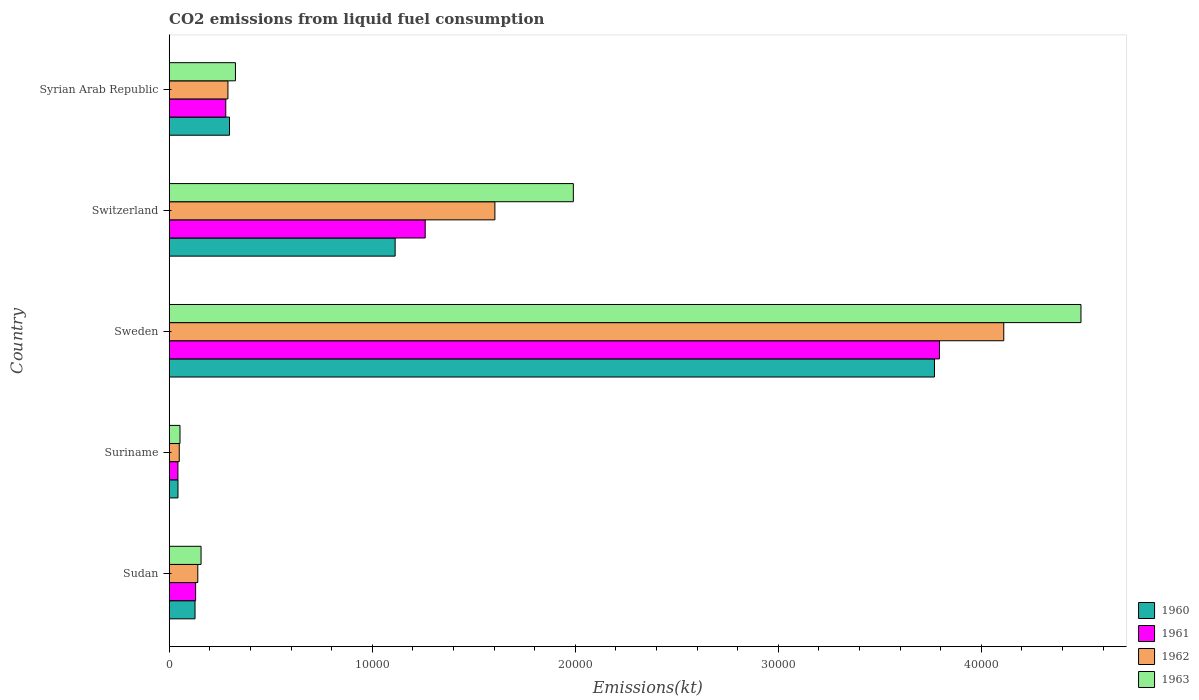How many different coloured bars are there?
Offer a very short reply. 4. Are the number of bars on each tick of the Y-axis equal?
Keep it short and to the point. Yes. How many bars are there on the 5th tick from the top?
Your answer should be very brief. 4. How many bars are there on the 2nd tick from the bottom?
Offer a very short reply. 4. What is the label of the 3rd group of bars from the top?
Your answer should be very brief. Sweden. What is the amount of CO2 emitted in 1960 in Syrian Arab Republic?
Provide a short and direct response. 2970.27. Across all countries, what is the maximum amount of CO2 emitted in 1961?
Provide a short and direct response. 3.79e+04. Across all countries, what is the minimum amount of CO2 emitted in 1962?
Your response must be concise. 495.05. In which country was the amount of CO2 emitted in 1960 minimum?
Make the answer very short. Suriname. What is the total amount of CO2 emitted in 1961 in the graph?
Provide a succinct answer. 5.51e+04. What is the difference between the amount of CO2 emitted in 1961 in Sweden and that in Switzerland?
Give a very brief answer. 2.53e+04. What is the difference between the amount of CO2 emitted in 1960 in Syrian Arab Republic and the amount of CO2 emitted in 1963 in Sweden?
Ensure brevity in your answer.  -4.19e+04. What is the average amount of CO2 emitted in 1963 per country?
Your answer should be compact. 1.40e+04. What is the difference between the amount of CO2 emitted in 1961 and amount of CO2 emitted in 1963 in Suriname?
Your answer should be compact. -102.68. In how many countries, is the amount of CO2 emitted in 1960 greater than 22000 kt?
Give a very brief answer. 1. What is the ratio of the amount of CO2 emitted in 1961 in Suriname to that in Syrian Arab Republic?
Give a very brief answer. 0.15. Is the amount of CO2 emitted in 1961 in Suriname less than that in Sweden?
Your answer should be compact. Yes. What is the difference between the highest and the second highest amount of CO2 emitted in 1961?
Offer a very short reply. 2.53e+04. What is the difference between the highest and the lowest amount of CO2 emitted in 1961?
Provide a short and direct response. 3.75e+04. In how many countries, is the amount of CO2 emitted in 1963 greater than the average amount of CO2 emitted in 1963 taken over all countries?
Provide a succinct answer. 2. Is it the case that in every country, the sum of the amount of CO2 emitted in 1963 and amount of CO2 emitted in 1961 is greater than the sum of amount of CO2 emitted in 1962 and amount of CO2 emitted in 1960?
Your answer should be compact. No. What does the 2nd bar from the top in Switzerland represents?
Offer a very short reply. 1962. How many bars are there?
Ensure brevity in your answer.  20. Does the graph contain any zero values?
Ensure brevity in your answer.  No. How many legend labels are there?
Make the answer very short. 4. How are the legend labels stacked?
Your response must be concise. Vertical. What is the title of the graph?
Provide a succinct answer. CO2 emissions from liquid fuel consumption. Does "1992" appear as one of the legend labels in the graph?
Provide a succinct answer. No. What is the label or title of the X-axis?
Your answer should be compact. Emissions(kt). What is the Emissions(kt) in 1960 in Sudan?
Offer a terse response. 1272.45. What is the Emissions(kt) in 1961 in Sudan?
Provide a short and direct response. 1301.79. What is the Emissions(kt) of 1962 in Sudan?
Make the answer very short. 1408.13. What is the Emissions(kt) of 1963 in Sudan?
Provide a succinct answer. 1569.48. What is the Emissions(kt) in 1960 in Suriname?
Keep it short and to the point. 432.71. What is the Emissions(kt) in 1961 in Suriname?
Your answer should be compact. 429.04. What is the Emissions(kt) in 1962 in Suriname?
Keep it short and to the point. 495.05. What is the Emissions(kt) of 1963 in Suriname?
Your answer should be very brief. 531.72. What is the Emissions(kt) in 1960 in Sweden?
Your answer should be very brief. 3.77e+04. What is the Emissions(kt) in 1961 in Sweden?
Make the answer very short. 3.79e+04. What is the Emissions(kt) of 1962 in Sweden?
Your response must be concise. 4.11e+04. What is the Emissions(kt) of 1963 in Sweden?
Keep it short and to the point. 4.49e+04. What is the Emissions(kt) in 1960 in Switzerland?
Make the answer very short. 1.11e+04. What is the Emissions(kt) of 1961 in Switzerland?
Offer a terse response. 1.26e+04. What is the Emissions(kt) of 1962 in Switzerland?
Keep it short and to the point. 1.60e+04. What is the Emissions(kt) in 1963 in Switzerland?
Offer a very short reply. 1.99e+04. What is the Emissions(kt) in 1960 in Syrian Arab Republic?
Offer a very short reply. 2970.27. What is the Emissions(kt) of 1961 in Syrian Arab Republic?
Provide a succinct answer. 2786.92. What is the Emissions(kt) of 1962 in Syrian Arab Republic?
Your response must be concise. 2893.26. What is the Emissions(kt) of 1963 in Syrian Arab Republic?
Your answer should be very brief. 3263.63. Across all countries, what is the maximum Emissions(kt) in 1960?
Your answer should be very brief. 3.77e+04. Across all countries, what is the maximum Emissions(kt) in 1961?
Provide a short and direct response. 3.79e+04. Across all countries, what is the maximum Emissions(kt) in 1962?
Your response must be concise. 4.11e+04. Across all countries, what is the maximum Emissions(kt) in 1963?
Provide a succinct answer. 4.49e+04. Across all countries, what is the minimum Emissions(kt) in 1960?
Keep it short and to the point. 432.71. Across all countries, what is the minimum Emissions(kt) of 1961?
Provide a short and direct response. 429.04. Across all countries, what is the minimum Emissions(kt) in 1962?
Ensure brevity in your answer.  495.05. Across all countries, what is the minimum Emissions(kt) of 1963?
Your answer should be very brief. 531.72. What is the total Emissions(kt) in 1960 in the graph?
Offer a terse response. 5.35e+04. What is the total Emissions(kt) in 1961 in the graph?
Your answer should be compact. 5.51e+04. What is the total Emissions(kt) of 1962 in the graph?
Provide a succinct answer. 6.20e+04. What is the total Emissions(kt) of 1963 in the graph?
Your answer should be very brief. 7.02e+04. What is the difference between the Emissions(kt) in 1960 in Sudan and that in Suriname?
Provide a short and direct response. 839.74. What is the difference between the Emissions(kt) of 1961 in Sudan and that in Suriname?
Offer a very short reply. 872.75. What is the difference between the Emissions(kt) of 1962 in Sudan and that in Suriname?
Provide a succinct answer. 913.08. What is the difference between the Emissions(kt) in 1963 in Sudan and that in Suriname?
Provide a succinct answer. 1037.76. What is the difference between the Emissions(kt) in 1960 in Sudan and that in Sweden?
Offer a terse response. -3.64e+04. What is the difference between the Emissions(kt) of 1961 in Sudan and that in Sweden?
Make the answer very short. -3.66e+04. What is the difference between the Emissions(kt) of 1962 in Sudan and that in Sweden?
Ensure brevity in your answer.  -3.97e+04. What is the difference between the Emissions(kt) of 1963 in Sudan and that in Sweden?
Provide a short and direct response. -4.33e+04. What is the difference between the Emissions(kt) of 1960 in Sudan and that in Switzerland?
Provide a succinct answer. -9856.9. What is the difference between the Emissions(kt) in 1961 in Sudan and that in Switzerland?
Ensure brevity in your answer.  -1.13e+04. What is the difference between the Emissions(kt) of 1962 in Sudan and that in Switzerland?
Your response must be concise. -1.46e+04. What is the difference between the Emissions(kt) in 1963 in Sudan and that in Switzerland?
Your response must be concise. -1.83e+04. What is the difference between the Emissions(kt) in 1960 in Sudan and that in Syrian Arab Republic?
Offer a terse response. -1697.82. What is the difference between the Emissions(kt) of 1961 in Sudan and that in Syrian Arab Republic?
Provide a short and direct response. -1485.13. What is the difference between the Emissions(kt) in 1962 in Sudan and that in Syrian Arab Republic?
Offer a terse response. -1485.13. What is the difference between the Emissions(kt) in 1963 in Sudan and that in Syrian Arab Republic?
Offer a very short reply. -1694.15. What is the difference between the Emissions(kt) in 1960 in Suriname and that in Sweden?
Ensure brevity in your answer.  -3.73e+04. What is the difference between the Emissions(kt) in 1961 in Suriname and that in Sweden?
Make the answer very short. -3.75e+04. What is the difference between the Emissions(kt) of 1962 in Suriname and that in Sweden?
Make the answer very short. -4.06e+04. What is the difference between the Emissions(kt) of 1963 in Suriname and that in Sweden?
Your response must be concise. -4.44e+04. What is the difference between the Emissions(kt) in 1960 in Suriname and that in Switzerland?
Offer a very short reply. -1.07e+04. What is the difference between the Emissions(kt) in 1961 in Suriname and that in Switzerland?
Offer a terse response. -1.22e+04. What is the difference between the Emissions(kt) in 1962 in Suriname and that in Switzerland?
Provide a short and direct response. -1.55e+04. What is the difference between the Emissions(kt) of 1963 in Suriname and that in Switzerland?
Provide a short and direct response. -1.94e+04. What is the difference between the Emissions(kt) in 1960 in Suriname and that in Syrian Arab Republic?
Keep it short and to the point. -2537.56. What is the difference between the Emissions(kt) of 1961 in Suriname and that in Syrian Arab Republic?
Keep it short and to the point. -2357.88. What is the difference between the Emissions(kt) in 1962 in Suriname and that in Syrian Arab Republic?
Keep it short and to the point. -2398.22. What is the difference between the Emissions(kt) of 1963 in Suriname and that in Syrian Arab Republic?
Ensure brevity in your answer.  -2731.91. What is the difference between the Emissions(kt) in 1960 in Sweden and that in Switzerland?
Keep it short and to the point. 2.66e+04. What is the difference between the Emissions(kt) of 1961 in Sweden and that in Switzerland?
Provide a short and direct response. 2.53e+04. What is the difference between the Emissions(kt) of 1962 in Sweden and that in Switzerland?
Keep it short and to the point. 2.51e+04. What is the difference between the Emissions(kt) in 1963 in Sweden and that in Switzerland?
Give a very brief answer. 2.50e+04. What is the difference between the Emissions(kt) of 1960 in Sweden and that in Syrian Arab Republic?
Offer a very short reply. 3.47e+04. What is the difference between the Emissions(kt) in 1961 in Sweden and that in Syrian Arab Republic?
Your response must be concise. 3.52e+04. What is the difference between the Emissions(kt) of 1962 in Sweden and that in Syrian Arab Republic?
Offer a terse response. 3.82e+04. What is the difference between the Emissions(kt) of 1963 in Sweden and that in Syrian Arab Republic?
Your response must be concise. 4.16e+04. What is the difference between the Emissions(kt) in 1960 in Switzerland and that in Syrian Arab Republic?
Keep it short and to the point. 8159.07. What is the difference between the Emissions(kt) in 1961 in Switzerland and that in Syrian Arab Republic?
Your answer should be very brief. 9823.89. What is the difference between the Emissions(kt) of 1962 in Switzerland and that in Syrian Arab Republic?
Your answer should be very brief. 1.31e+04. What is the difference between the Emissions(kt) of 1963 in Switzerland and that in Syrian Arab Republic?
Make the answer very short. 1.66e+04. What is the difference between the Emissions(kt) of 1960 in Sudan and the Emissions(kt) of 1961 in Suriname?
Provide a succinct answer. 843.41. What is the difference between the Emissions(kt) in 1960 in Sudan and the Emissions(kt) in 1962 in Suriname?
Give a very brief answer. 777.4. What is the difference between the Emissions(kt) of 1960 in Sudan and the Emissions(kt) of 1963 in Suriname?
Offer a terse response. 740.73. What is the difference between the Emissions(kt) of 1961 in Sudan and the Emissions(kt) of 1962 in Suriname?
Make the answer very short. 806.74. What is the difference between the Emissions(kt) in 1961 in Sudan and the Emissions(kt) in 1963 in Suriname?
Your response must be concise. 770.07. What is the difference between the Emissions(kt) in 1962 in Sudan and the Emissions(kt) in 1963 in Suriname?
Your response must be concise. 876.41. What is the difference between the Emissions(kt) in 1960 in Sudan and the Emissions(kt) in 1961 in Sweden?
Offer a terse response. -3.67e+04. What is the difference between the Emissions(kt) of 1960 in Sudan and the Emissions(kt) of 1962 in Sweden?
Make the answer very short. -3.98e+04. What is the difference between the Emissions(kt) of 1960 in Sudan and the Emissions(kt) of 1963 in Sweden?
Your response must be concise. -4.36e+04. What is the difference between the Emissions(kt) in 1961 in Sudan and the Emissions(kt) in 1962 in Sweden?
Your response must be concise. -3.98e+04. What is the difference between the Emissions(kt) in 1961 in Sudan and the Emissions(kt) in 1963 in Sweden?
Keep it short and to the point. -4.36e+04. What is the difference between the Emissions(kt) in 1962 in Sudan and the Emissions(kt) in 1963 in Sweden?
Offer a terse response. -4.35e+04. What is the difference between the Emissions(kt) in 1960 in Sudan and the Emissions(kt) in 1961 in Switzerland?
Provide a short and direct response. -1.13e+04. What is the difference between the Emissions(kt) in 1960 in Sudan and the Emissions(kt) in 1962 in Switzerland?
Give a very brief answer. -1.48e+04. What is the difference between the Emissions(kt) in 1960 in Sudan and the Emissions(kt) in 1963 in Switzerland?
Make the answer very short. -1.86e+04. What is the difference between the Emissions(kt) of 1961 in Sudan and the Emissions(kt) of 1962 in Switzerland?
Make the answer very short. -1.47e+04. What is the difference between the Emissions(kt) in 1961 in Sudan and the Emissions(kt) in 1963 in Switzerland?
Ensure brevity in your answer.  -1.86e+04. What is the difference between the Emissions(kt) in 1962 in Sudan and the Emissions(kt) in 1963 in Switzerland?
Your answer should be compact. -1.85e+04. What is the difference between the Emissions(kt) of 1960 in Sudan and the Emissions(kt) of 1961 in Syrian Arab Republic?
Your answer should be very brief. -1514.47. What is the difference between the Emissions(kt) of 1960 in Sudan and the Emissions(kt) of 1962 in Syrian Arab Republic?
Your answer should be compact. -1620.81. What is the difference between the Emissions(kt) in 1960 in Sudan and the Emissions(kt) in 1963 in Syrian Arab Republic?
Give a very brief answer. -1991.18. What is the difference between the Emissions(kt) of 1961 in Sudan and the Emissions(kt) of 1962 in Syrian Arab Republic?
Your answer should be compact. -1591.48. What is the difference between the Emissions(kt) in 1961 in Sudan and the Emissions(kt) in 1963 in Syrian Arab Republic?
Make the answer very short. -1961.85. What is the difference between the Emissions(kt) of 1962 in Sudan and the Emissions(kt) of 1963 in Syrian Arab Republic?
Offer a very short reply. -1855.5. What is the difference between the Emissions(kt) in 1960 in Suriname and the Emissions(kt) in 1961 in Sweden?
Keep it short and to the point. -3.75e+04. What is the difference between the Emissions(kt) of 1960 in Suriname and the Emissions(kt) of 1962 in Sweden?
Provide a short and direct response. -4.07e+04. What is the difference between the Emissions(kt) in 1960 in Suriname and the Emissions(kt) in 1963 in Sweden?
Your answer should be very brief. -4.45e+04. What is the difference between the Emissions(kt) of 1961 in Suriname and the Emissions(kt) of 1962 in Sweden?
Your answer should be very brief. -4.07e+04. What is the difference between the Emissions(kt) in 1961 in Suriname and the Emissions(kt) in 1963 in Sweden?
Offer a very short reply. -4.45e+04. What is the difference between the Emissions(kt) of 1962 in Suriname and the Emissions(kt) of 1963 in Sweden?
Make the answer very short. -4.44e+04. What is the difference between the Emissions(kt) in 1960 in Suriname and the Emissions(kt) in 1961 in Switzerland?
Offer a terse response. -1.22e+04. What is the difference between the Emissions(kt) in 1960 in Suriname and the Emissions(kt) in 1962 in Switzerland?
Provide a succinct answer. -1.56e+04. What is the difference between the Emissions(kt) in 1960 in Suriname and the Emissions(kt) in 1963 in Switzerland?
Provide a succinct answer. -1.95e+04. What is the difference between the Emissions(kt) of 1961 in Suriname and the Emissions(kt) of 1962 in Switzerland?
Your response must be concise. -1.56e+04. What is the difference between the Emissions(kt) of 1961 in Suriname and the Emissions(kt) of 1963 in Switzerland?
Give a very brief answer. -1.95e+04. What is the difference between the Emissions(kt) in 1962 in Suriname and the Emissions(kt) in 1963 in Switzerland?
Offer a very short reply. -1.94e+04. What is the difference between the Emissions(kt) in 1960 in Suriname and the Emissions(kt) in 1961 in Syrian Arab Republic?
Provide a succinct answer. -2354.21. What is the difference between the Emissions(kt) in 1960 in Suriname and the Emissions(kt) in 1962 in Syrian Arab Republic?
Keep it short and to the point. -2460.56. What is the difference between the Emissions(kt) of 1960 in Suriname and the Emissions(kt) of 1963 in Syrian Arab Republic?
Offer a terse response. -2830.92. What is the difference between the Emissions(kt) of 1961 in Suriname and the Emissions(kt) of 1962 in Syrian Arab Republic?
Ensure brevity in your answer.  -2464.22. What is the difference between the Emissions(kt) of 1961 in Suriname and the Emissions(kt) of 1963 in Syrian Arab Republic?
Give a very brief answer. -2834.59. What is the difference between the Emissions(kt) in 1962 in Suriname and the Emissions(kt) in 1963 in Syrian Arab Republic?
Give a very brief answer. -2768.59. What is the difference between the Emissions(kt) of 1960 in Sweden and the Emissions(kt) of 1961 in Switzerland?
Make the answer very short. 2.51e+04. What is the difference between the Emissions(kt) in 1960 in Sweden and the Emissions(kt) in 1962 in Switzerland?
Offer a very short reply. 2.17e+04. What is the difference between the Emissions(kt) in 1960 in Sweden and the Emissions(kt) in 1963 in Switzerland?
Keep it short and to the point. 1.78e+04. What is the difference between the Emissions(kt) of 1961 in Sweden and the Emissions(kt) of 1962 in Switzerland?
Provide a succinct answer. 2.19e+04. What is the difference between the Emissions(kt) of 1961 in Sweden and the Emissions(kt) of 1963 in Switzerland?
Offer a very short reply. 1.80e+04. What is the difference between the Emissions(kt) in 1962 in Sweden and the Emissions(kt) in 1963 in Switzerland?
Offer a terse response. 2.12e+04. What is the difference between the Emissions(kt) in 1960 in Sweden and the Emissions(kt) in 1961 in Syrian Arab Republic?
Offer a very short reply. 3.49e+04. What is the difference between the Emissions(kt) in 1960 in Sweden and the Emissions(kt) in 1962 in Syrian Arab Republic?
Provide a succinct answer. 3.48e+04. What is the difference between the Emissions(kt) of 1960 in Sweden and the Emissions(kt) of 1963 in Syrian Arab Republic?
Make the answer very short. 3.44e+04. What is the difference between the Emissions(kt) in 1961 in Sweden and the Emissions(kt) in 1962 in Syrian Arab Republic?
Provide a succinct answer. 3.50e+04. What is the difference between the Emissions(kt) of 1961 in Sweden and the Emissions(kt) of 1963 in Syrian Arab Republic?
Keep it short and to the point. 3.47e+04. What is the difference between the Emissions(kt) of 1962 in Sweden and the Emissions(kt) of 1963 in Syrian Arab Republic?
Give a very brief answer. 3.78e+04. What is the difference between the Emissions(kt) of 1960 in Switzerland and the Emissions(kt) of 1961 in Syrian Arab Republic?
Keep it short and to the point. 8342.42. What is the difference between the Emissions(kt) of 1960 in Switzerland and the Emissions(kt) of 1962 in Syrian Arab Republic?
Give a very brief answer. 8236.08. What is the difference between the Emissions(kt) in 1960 in Switzerland and the Emissions(kt) in 1963 in Syrian Arab Republic?
Your answer should be very brief. 7865.72. What is the difference between the Emissions(kt) of 1961 in Switzerland and the Emissions(kt) of 1962 in Syrian Arab Republic?
Give a very brief answer. 9717.55. What is the difference between the Emissions(kt) of 1961 in Switzerland and the Emissions(kt) of 1963 in Syrian Arab Republic?
Your response must be concise. 9347.18. What is the difference between the Emissions(kt) of 1962 in Switzerland and the Emissions(kt) of 1963 in Syrian Arab Republic?
Keep it short and to the point. 1.28e+04. What is the average Emissions(kt) of 1960 per country?
Keep it short and to the point. 1.07e+04. What is the average Emissions(kt) of 1961 per country?
Your answer should be compact. 1.10e+04. What is the average Emissions(kt) in 1962 per country?
Provide a succinct answer. 1.24e+04. What is the average Emissions(kt) of 1963 per country?
Offer a terse response. 1.40e+04. What is the difference between the Emissions(kt) in 1960 and Emissions(kt) in 1961 in Sudan?
Your answer should be compact. -29.34. What is the difference between the Emissions(kt) of 1960 and Emissions(kt) of 1962 in Sudan?
Your answer should be very brief. -135.68. What is the difference between the Emissions(kt) in 1960 and Emissions(kt) in 1963 in Sudan?
Your answer should be compact. -297.03. What is the difference between the Emissions(kt) in 1961 and Emissions(kt) in 1962 in Sudan?
Make the answer very short. -106.34. What is the difference between the Emissions(kt) of 1961 and Emissions(kt) of 1963 in Sudan?
Offer a terse response. -267.69. What is the difference between the Emissions(kt) of 1962 and Emissions(kt) of 1963 in Sudan?
Ensure brevity in your answer.  -161.35. What is the difference between the Emissions(kt) of 1960 and Emissions(kt) of 1961 in Suriname?
Your answer should be very brief. 3.67. What is the difference between the Emissions(kt) in 1960 and Emissions(kt) in 1962 in Suriname?
Ensure brevity in your answer.  -62.34. What is the difference between the Emissions(kt) of 1960 and Emissions(kt) of 1963 in Suriname?
Your answer should be compact. -99.01. What is the difference between the Emissions(kt) in 1961 and Emissions(kt) in 1962 in Suriname?
Your response must be concise. -66.01. What is the difference between the Emissions(kt) of 1961 and Emissions(kt) of 1963 in Suriname?
Offer a very short reply. -102.68. What is the difference between the Emissions(kt) of 1962 and Emissions(kt) of 1963 in Suriname?
Provide a short and direct response. -36.67. What is the difference between the Emissions(kt) of 1960 and Emissions(kt) of 1961 in Sweden?
Offer a terse response. -245.69. What is the difference between the Emissions(kt) in 1960 and Emissions(kt) in 1962 in Sweden?
Offer a very short reply. -3413.98. What is the difference between the Emissions(kt) of 1960 and Emissions(kt) of 1963 in Sweden?
Offer a terse response. -7216.66. What is the difference between the Emissions(kt) in 1961 and Emissions(kt) in 1962 in Sweden?
Ensure brevity in your answer.  -3168.29. What is the difference between the Emissions(kt) in 1961 and Emissions(kt) in 1963 in Sweden?
Provide a short and direct response. -6970.97. What is the difference between the Emissions(kt) of 1962 and Emissions(kt) of 1963 in Sweden?
Provide a short and direct response. -3802.68. What is the difference between the Emissions(kt) of 1960 and Emissions(kt) of 1961 in Switzerland?
Your answer should be compact. -1481.47. What is the difference between the Emissions(kt) of 1960 and Emissions(kt) of 1962 in Switzerland?
Your response must be concise. -4913.78. What is the difference between the Emissions(kt) in 1960 and Emissions(kt) in 1963 in Switzerland?
Offer a very short reply. -8778.8. What is the difference between the Emissions(kt) in 1961 and Emissions(kt) in 1962 in Switzerland?
Keep it short and to the point. -3432.31. What is the difference between the Emissions(kt) of 1961 and Emissions(kt) of 1963 in Switzerland?
Keep it short and to the point. -7297.33. What is the difference between the Emissions(kt) of 1962 and Emissions(kt) of 1963 in Switzerland?
Offer a terse response. -3865.02. What is the difference between the Emissions(kt) in 1960 and Emissions(kt) in 1961 in Syrian Arab Republic?
Offer a very short reply. 183.35. What is the difference between the Emissions(kt) in 1960 and Emissions(kt) in 1962 in Syrian Arab Republic?
Your response must be concise. 77.01. What is the difference between the Emissions(kt) of 1960 and Emissions(kt) of 1963 in Syrian Arab Republic?
Your answer should be compact. -293.36. What is the difference between the Emissions(kt) in 1961 and Emissions(kt) in 1962 in Syrian Arab Republic?
Your response must be concise. -106.34. What is the difference between the Emissions(kt) in 1961 and Emissions(kt) in 1963 in Syrian Arab Republic?
Ensure brevity in your answer.  -476.71. What is the difference between the Emissions(kt) of 1962 and Emissions(kt) of 1963 in Syrian Arab Republic?
Provide a short and direct response. -370.37. What is the ratio of the Emissions(kt) in 1960 in Sudan to that in Suriname?
Keep it short and to the point. 2.94. What is the ratio of the Emissions(kt) in 1961 in Sudan to that in Suriname?
Make the answer very short. 3.03. What is the ratio of the Emissions(kt) of 1962 in Sudan to that in Suriname?
Your response must be concise. 2.84. What is the ratio of the Emissions(kt) of 1963 in Sudan to that in Suriname?
Your answer should be compact. 2.95. What is the ratio of the Emissions(kt) of 1960 in Sudan to that in Sweden?
Make the answer very short. 0.03. What is the ratio of the Emissions(kt) of 1961 in Sudan to that in Sweden?
Offer a very short reply. 0.03. What is the ratio of the Emissions(kt) of 1962 in Sudan to that in Sweden?
Give a very brief answer. 0.03. What is the ratio of the Emissions(kt) of 1963 in Sudan to that in Sweden?
Offer a terse response. 0.03. What is the ratio of the Emissions(kt) of 1960 in Sudan to that in Switzerland?
Your answer should be compact. 0.11. What is the ratio of the Emissions(kt) in 1961 in Sudan to that in Switzerland?
Provide a succinct answer. 0.1. What is the ratio of the Emissions(kt) of 1962 in Sudan to that in Switzerland?
Ensure brevity in your answer.  0.09. What is the ratio of the Emissions(kt) of 1963 in Sudan to that in Switzerland?
Ensure brevity in your answer.  0.08. What is the ratio of the Emissions(kt) of 1960 in Sudan to that in Syrian Arab Republic?
Make the answer very short. 0.43. What is the ratio of the Emissions(kt) in 1961 in Sudan to that in Syrian Arab Republic?
Provide a succinct answer. 0.47. What is the ratio of the Emissions(kt) in 1962 in Sudan to that in Syrian Arab Republic?
Offer a very short reply. 0.49. What is the ratio of the Emissions(kt) of 1963 in Sudan to that in Syrian Arab Republic?
Ensure brevity in your answer.  0.48. What is the ratio of the Emissions(kt) in 1960 in Suriname to that in Sweden?
Keep it short and to the point. 0.01. What is the ratio of the Emissions(kt) of 1961 in Suriname to that in Sweden?
Your response must be concise. 0.01. What is the ratio of the Emissions(kt) in 1962 in Suriname to that in Sweden?
Your answer should be very brief. 0.01. What is the ratio of the Emissions(kt) of 1963 in Suriname to that in Sweden?
Give a very brief answer. 0.01. What is the ratio of the Emissions(kt) of 1960 in Suriname to that in Switzerland?
Provide a succinct answer. 0.04. What is the ratio of the Emissions(kt) in 1961 in Suriname to that in Switzerland?
Your answer should be compact. 0.03. What is the ratio of the Emissions(kt) in 1962 in Suriname to that in Switzerland?
Your answer should be compact. 0.03. What is the ratio of the Emissions(kt) in 1963 in Suriname to that in Switzerland?
Provide a succinct answer. 0.03. What is the ratio of the Emissions(kt) in 1960 in Suriname to that in Syrian Arab Republic?
Offer a terse response. 0.15. What is the ratio of the Emissions(kt) in 1961 in Suriname to that in Syrian Arab Republic?
Your response must be concise. 0.15. What is the ratio of the Emissions(kt) in 1962 in Suriname to that in Syrian Arab Republic?
Make the answer very short. 0.17. What is the ratio of the Emissions(kt) of 1963 in Suriname to that in Syrian Arab Republic?
Provide a succinct answer. 0.16. What is the ratio of the Emissions(kt) of 1960 in Sweden to that in Switzerland?
Provide a short and direct response. 3.39. What is the ratio of the Emissions(kt) in 1961 in Sweden to that in Switzerland?
Give a very brief answer. 3.01. What is the ratio of the Emissions(kt) in 1962 in Sweden to that in Switzerland?
Offer a terse response. 2.56. What is the ratio of the Emissions(kt) of 1963 in Sweden to that in Switzerland?
Provide a succinct answer. 2.26. What is the ratio of the Emissions(kt) in 1960 in Sweden to that in Syrian Arab Republic?
Your answer should be very brief. 12.69. What is the ratio of the Emissions(kt) in 1961 in Sweden to that in Syrian Arab Republic?
Provide a short and direct response. 13.61. What is the ratio of the Emissions(kt) of 1962 in Sweden to that in Syrian Arab Republic?
Keep it short and to the point. 14.21. What is the ratio of the Emissions(kt) in 1963 in Sweden to that in Syrian Arab Republic?
Offer a terse response. 13.76. What is the ratio of the Emissions(kt) in 1960 in Switzerland to that in Syrian Arab Republic?
Offer a very short reply. 3.75. What is the ratio of the Emissions(kt) in 1961 in Switzerland to that in Syrian Arab Republic?
Offer a very short reply. 4.53. What is the ratio of the Emissions(kt) in 1962 in Switzerland to that in Syrian Arab Republic?
Give a very brief answer. 5.54. What is the difference between the highest and the second highest Emissions(kt) in 1960?
Provide a short and direct response. 2.66e+04. What is the difference between the highest and the second highest Emissions(kt) of 1961?
Offer a very short reply. 2.53e+04. What is the difference between the highest and the second highest Emissions(kt) in 1962?
Offer a very short reply. 2.51e+04. What is the difference between the highest and the second highest Emissions(kt) of 1963?
Provide a succinct answer. 2.50e+04. What is the difference between the highest and the lowest Emissions(kt) in 1960?
Keep it short and to the point. 3.73e+04. What is the difference between the highest and the lowest Emissions(kt) in 1961?
Keep it short and to the point. 3.75e+04. What is the difference between the highest and the lowest Emissions(kt) in 1962?
Ensure brevity in your answer.  4.06e+04. What is the difference between the highest and the lowest Emissions(kt) in 1963?
Provide a succinct answer. 4.44e+04. 